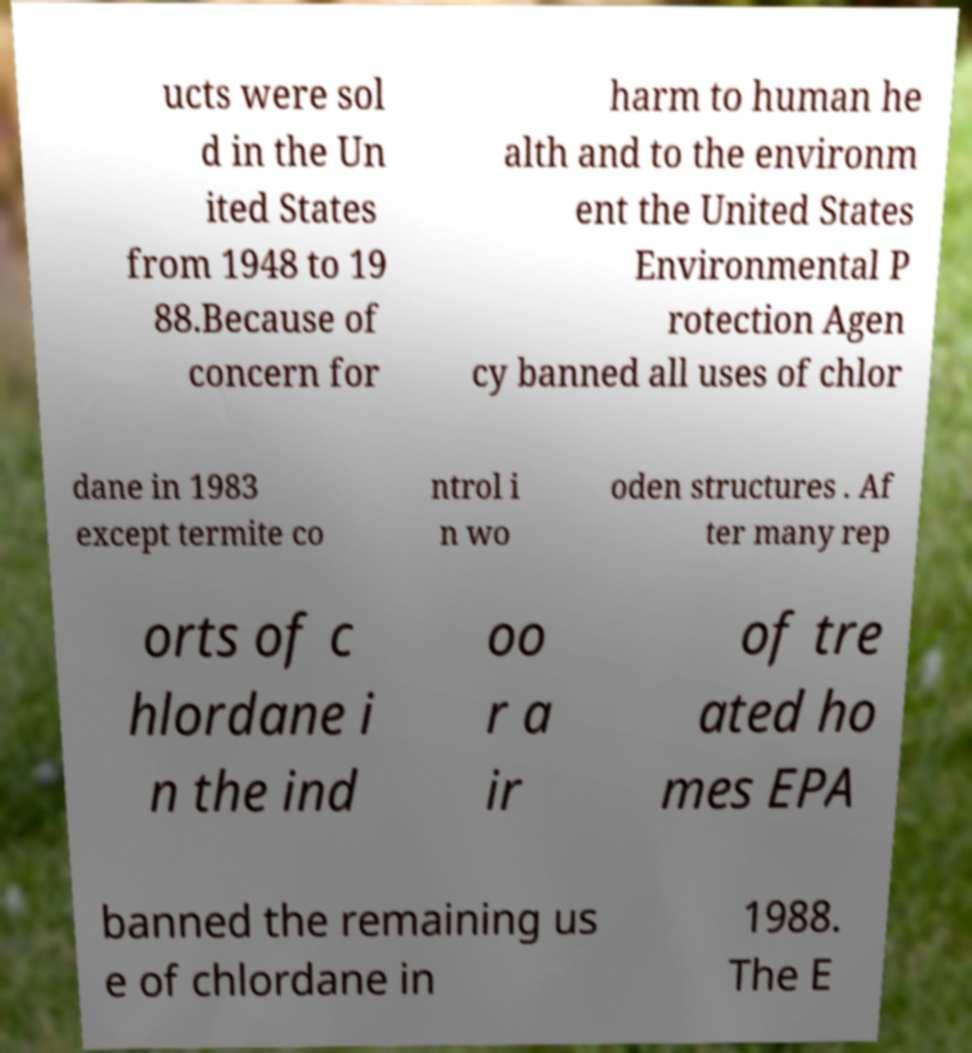Please identify and transcribe the text found in this image. ucts were sol d in the Un ited States from 1948 to 19 88.Because of concern for harm to human he alth and to the environm ent the United States Environmental P rotection Agen cy banned all uses of chlor dane in 1983 except termite co ntrol i n wo oden structures . Af ter many rep orts of c hlordane i n the ind oo r a ir of tre ated ho mes EPA banned the remaining us e of chlordane in 1988. The E 